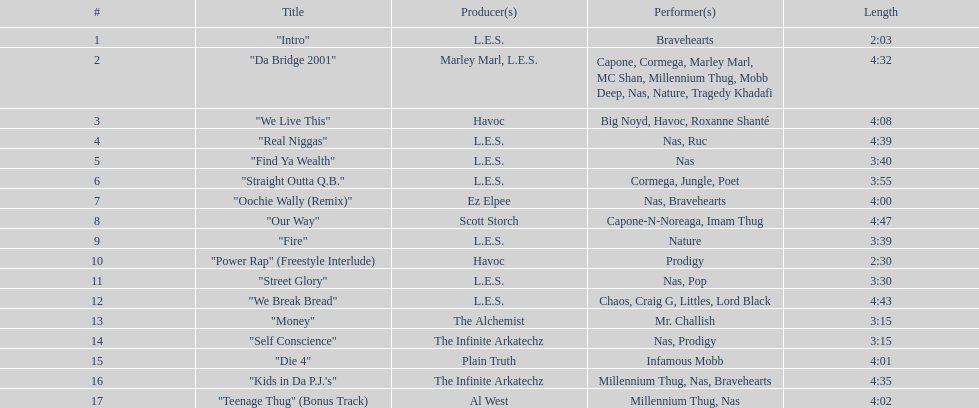Which artists were in the final track? Millennium Thug, Nas. 